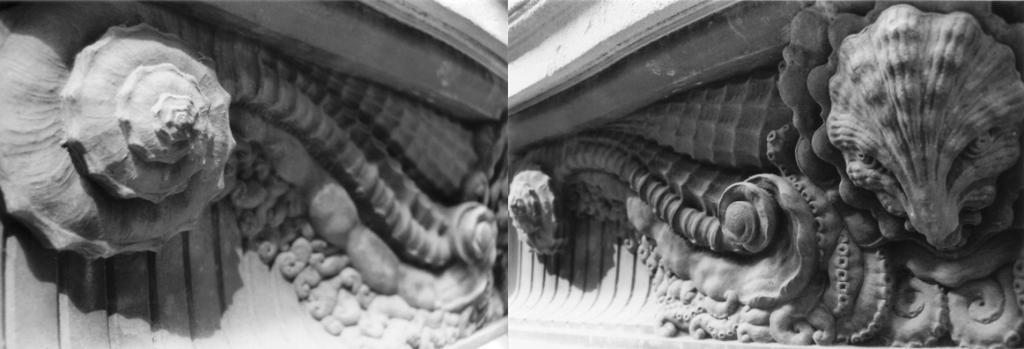What is depicted on the wall in the image? There is a college of sculptures on the wall in the image. What type of spoon is being used by the lawyer at the dock in the image? There is no spoon, lawyer, or dock present in the image; it only features a college of sculptures on the wall. 